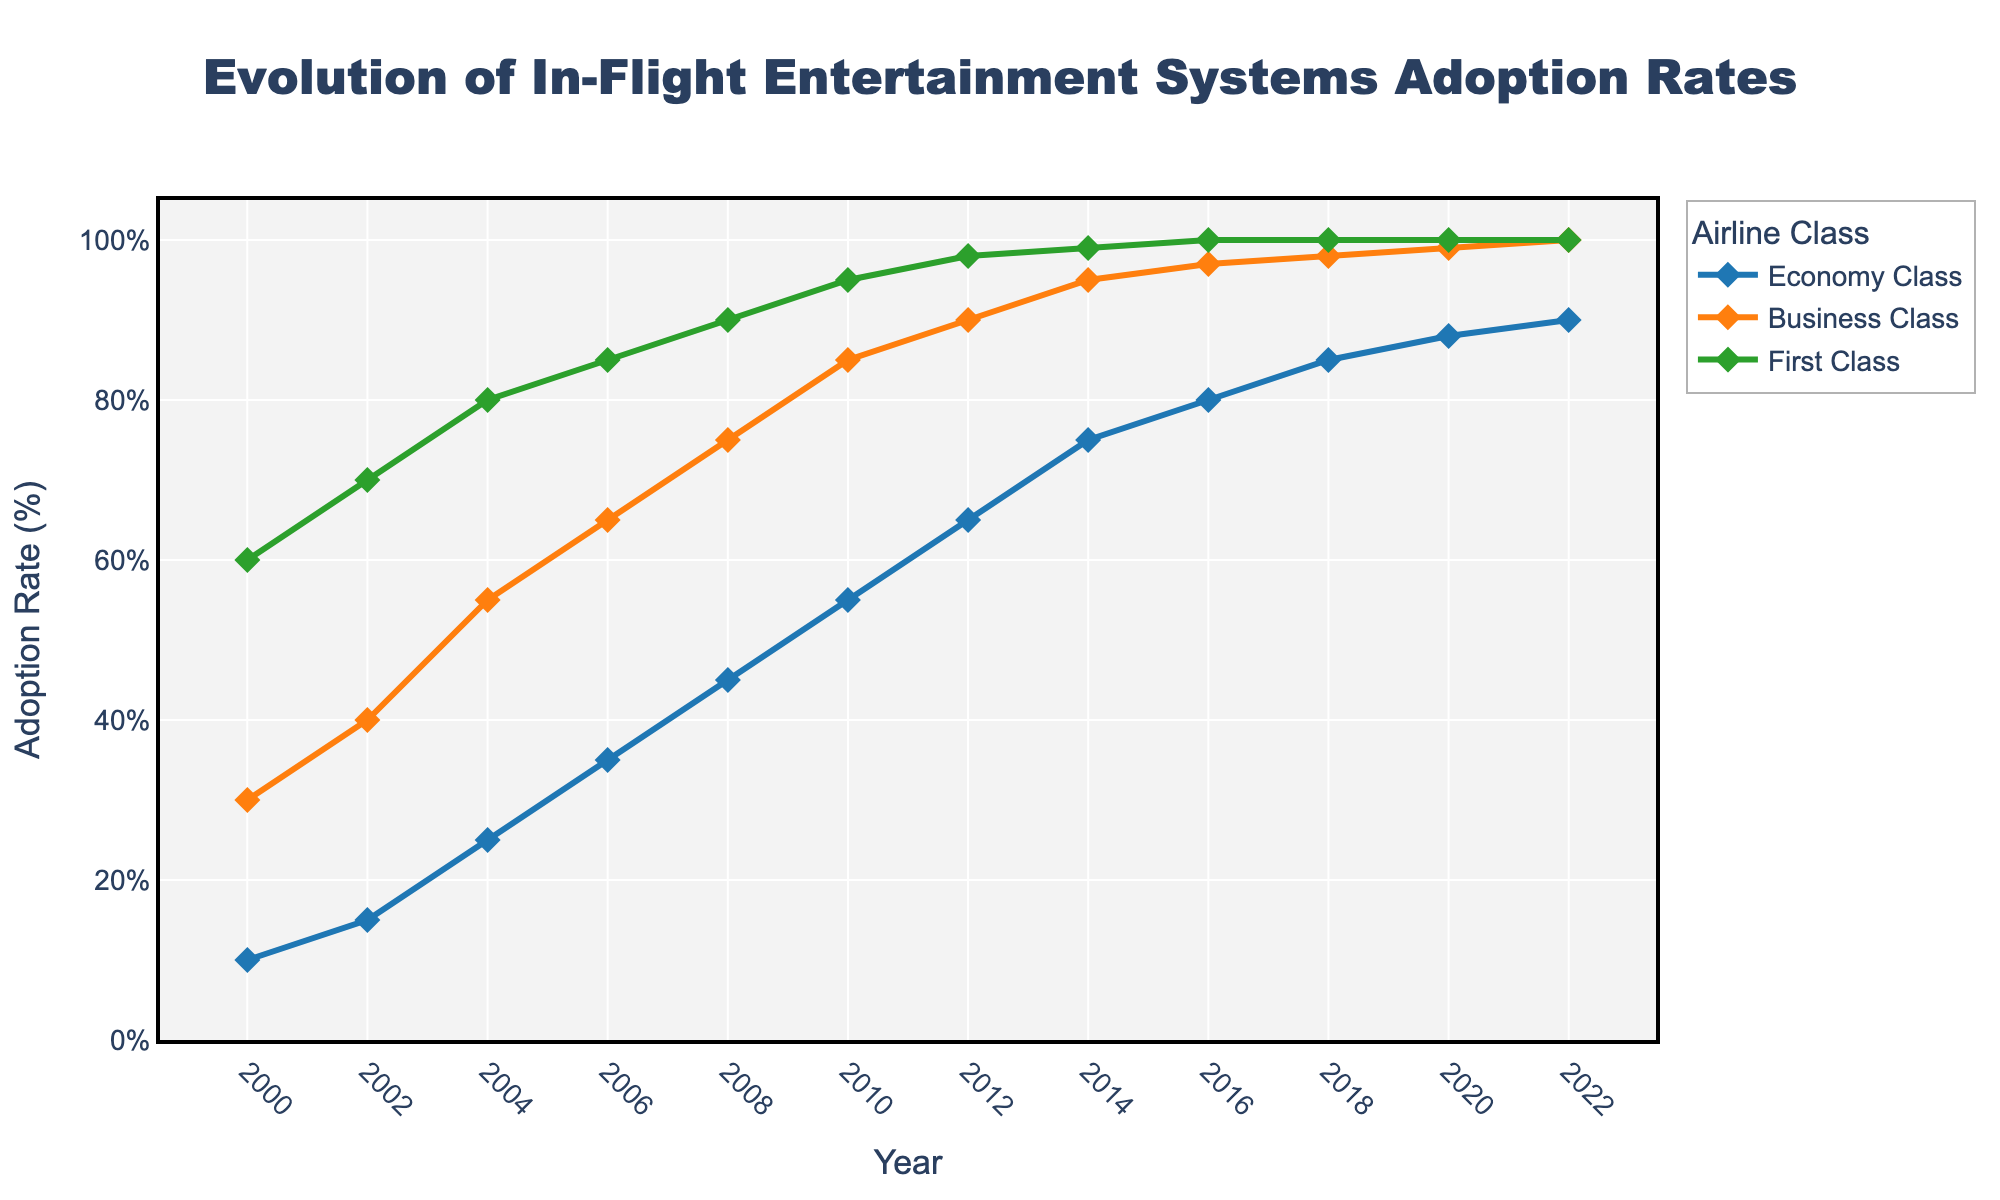What was the adoption rate of in-flight entertainment systems in Economy Class in 2012? Locate the line for Economy Class and find the value corresponding to the year 2012.
Answer: 65 Which airline class reached a 100% adoption rate first and in which year did this occur? By observing the lines for each class, note that First Class reached 100% adoption in 2016, whereas the other classes reached this threshold in later years.
Answer: First Class, 2016 Has Business Class always had a higher adoption rate than Economy Class? Compare the two lines from 2000 to 2022, noting that at every point, the Business Class line is above the Economy Class line.
Answer: Yes In which year did First Class adoption rate reach 95%? Trace the line for First Class until it hits the 95% mark, which occurs in 2014.
Answer: 2014 What is the difference in adoption rates between Business Class and Economy Class in 2010? Find the values for Business Class and Economy Class in 2010 (85% and 55% respectively) and subtract to get the difference, 85 - 55.
Answer: 30% Between 2000 and 2002, which airline class showed the highest rate of increase in adoption? Calculate the increase for each class: Economy Class (15-10 = 5), Business Class (40-30 = 10), First Class (70-60 = 10). Business and First Class both increased by 10 percentage points, which is higher than Economy Class.
Answer: Business Class and First Class What color represents the First Class line in the chart? Observe the color of the line labeled as First Class, which is green.
Answer: Green How many years did it take for Economy Class to reach an 80% adoption rate? Identify the year when Economy Class crosses 80% (2016) and subtract the starting year 2000, resulting in 2016 - 2000.
Answer: 16 years In which year do all three classes have an adoption rate of at least 85%? Identify the earliest year where all three lines are at or above 85%. This occurs in 2018.
Answer: 2018 